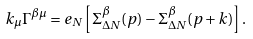<formula> <loc_0><loc_0><loc_500><loc_500>k _ { \mu } \Gamma ^ { \beta \mu } = e _ { N } \left [ \Sigma ^ { \beta } _ { \Delta N } ( p ) - \Sigma ^ { \beta } _ { \Delta N } ( p + k ) \right ] .</formula> 